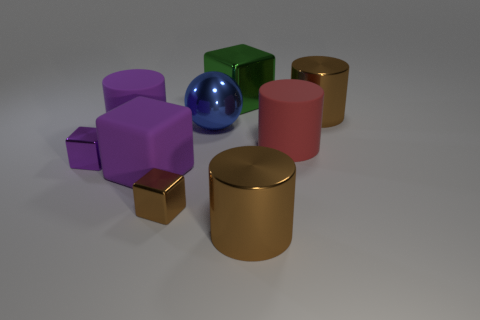How many other objects are there of the same color as the ball?
Provide a succinct answer. 0. How many other things are made of the same material as the large green cube?
Offer a terse response. 5. There is a red object; is it the same size as the blue sphere that is on the right side of the tiny purple shiny block?
Your answer should be compact. Yes. The large sphere has what color?
Provide a short and direct response. Blue. The large brown object that is on the right side of the metal cylinder to the left of the cylinder behind the purple rubber cylinder is what shape?
Keep it short and to the point. Cylinder. There is a small cube that is in front of the small thing behind the small brown metal block; what is it made of?
Provide a short and direct response. Metal. What is the shape of the small purple object that is made of the same material as the large blue sphere?
Your answer should be very brief. Cube. Is there any other thing that is the same shape as the large blue object?
Provide a short and direct response. No. How many large cubes are on the right side of the large shiny sphere?
Make the answer very short. 1. Are there any green shiny things?
Your response must be concise. Yes. 